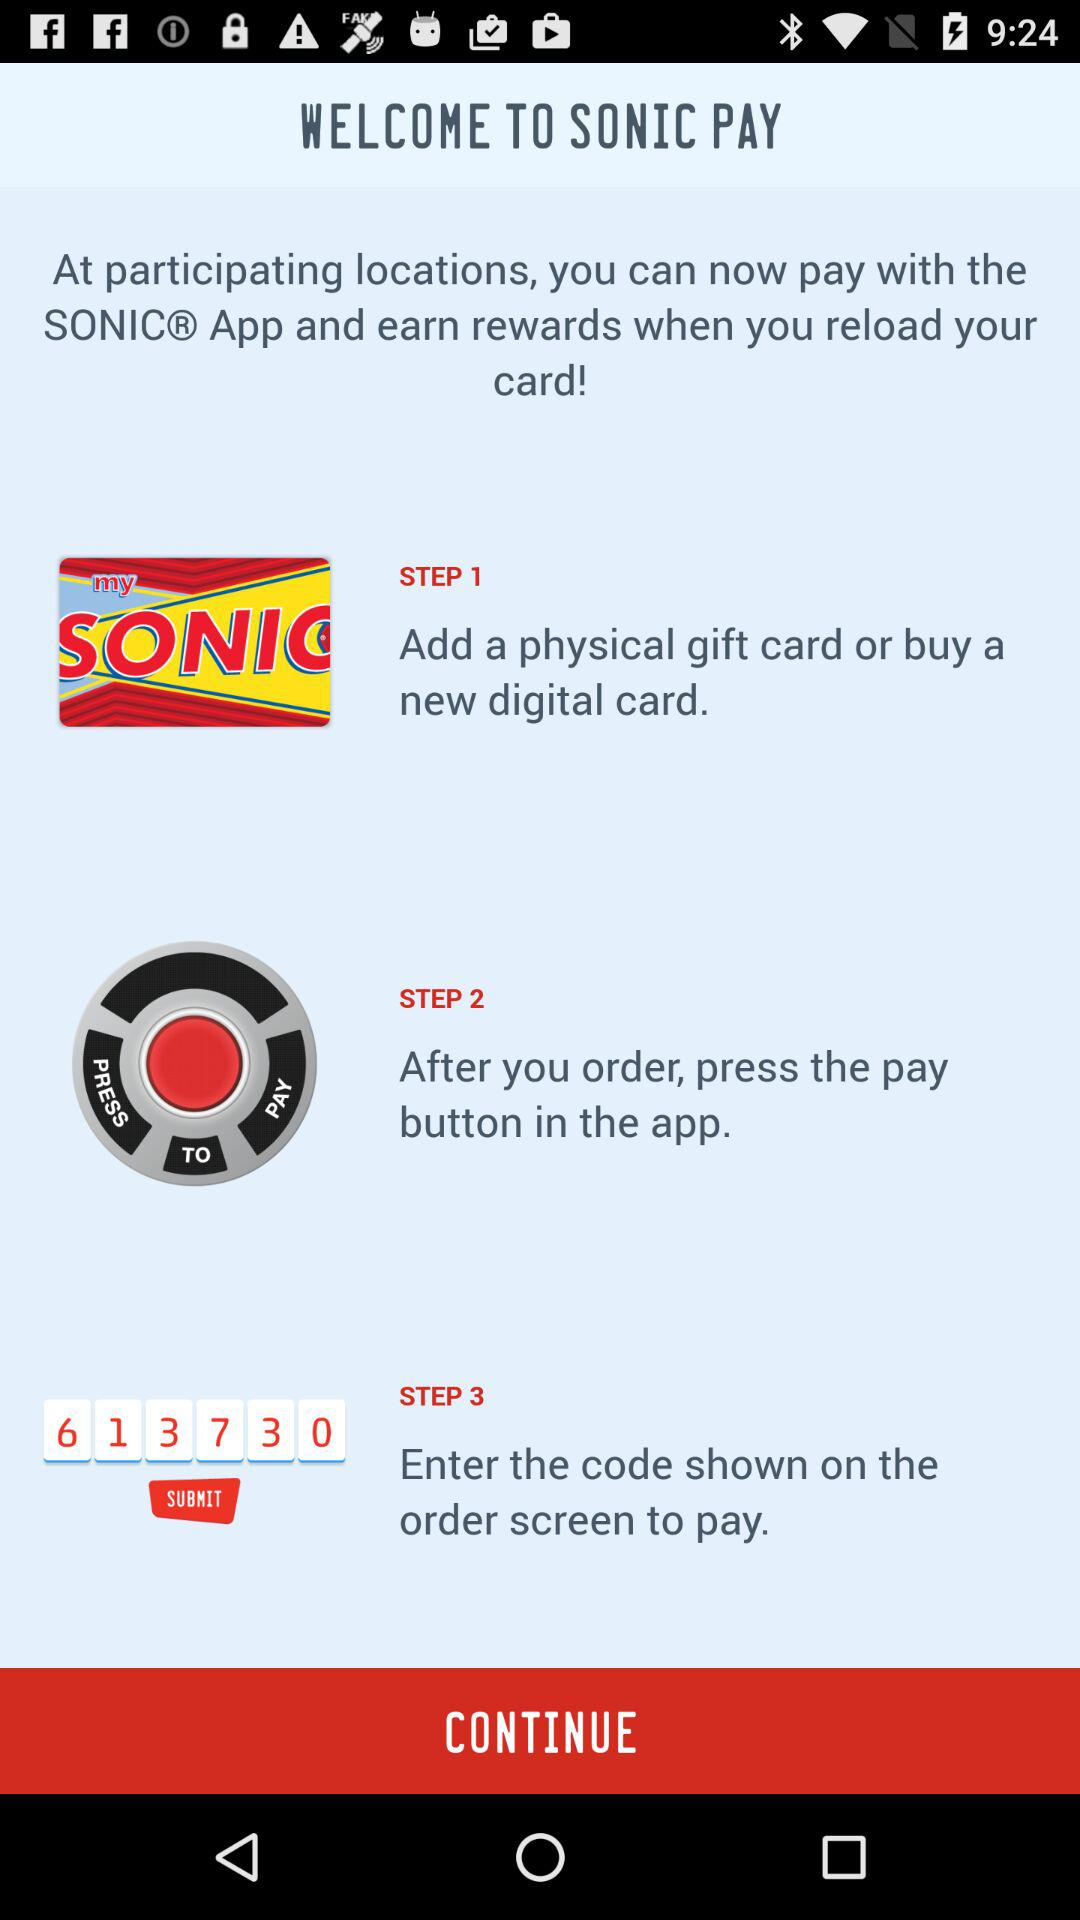How many steps are in the process?
Answer the question using a single word or phrase. 3 